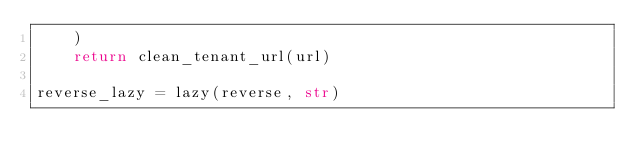<code> <loc_0><loc_0><loc_500><loc_500><_Python_>    )
    return clean_tenant_url(url)

reverse_lazy = lazy(reverse, str)
</code> 